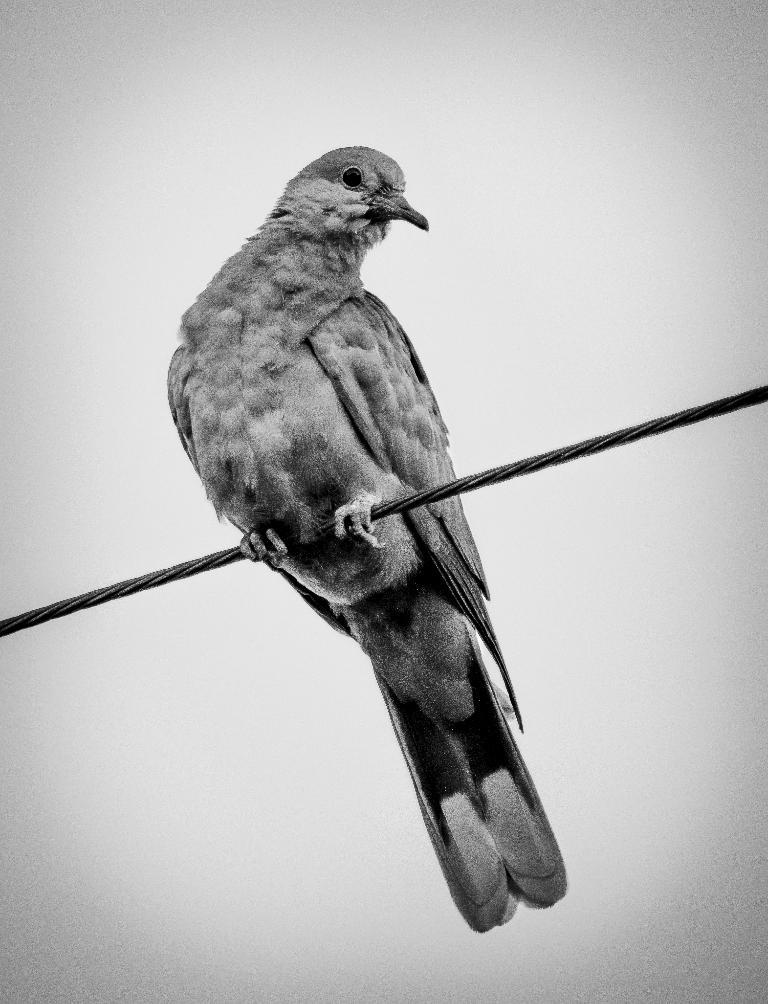What type of animal can be seen in the image? There is a bird in the image. Where is the bird located? The bird is standing on an electric wire. What can be seen in the background of the image? The sky is visible in the background of the image. What type of flowers can be seen growing near the bird in the image? There are no flowers present in the image; it only shows a bird standing on an electric wire with the sky visible in the background. There are no flowers in the image, as the facts provided only mention a bird on an electric wire and the sky in the background. 